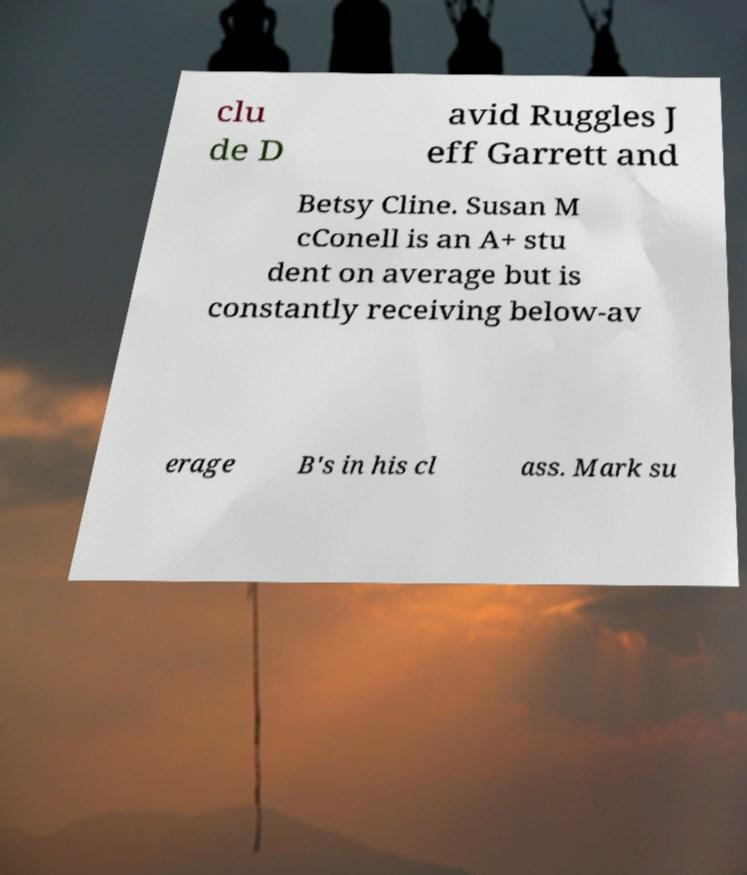What messages or text are displayed in this image? I need them in a readable, typed format. clu de D avid Ruggles J eff Garrett and Betsy Cline. Susan M cConell is an A+ stu dent on average but is constantly receiving below-av erage B's in his cl ass. Mark su 